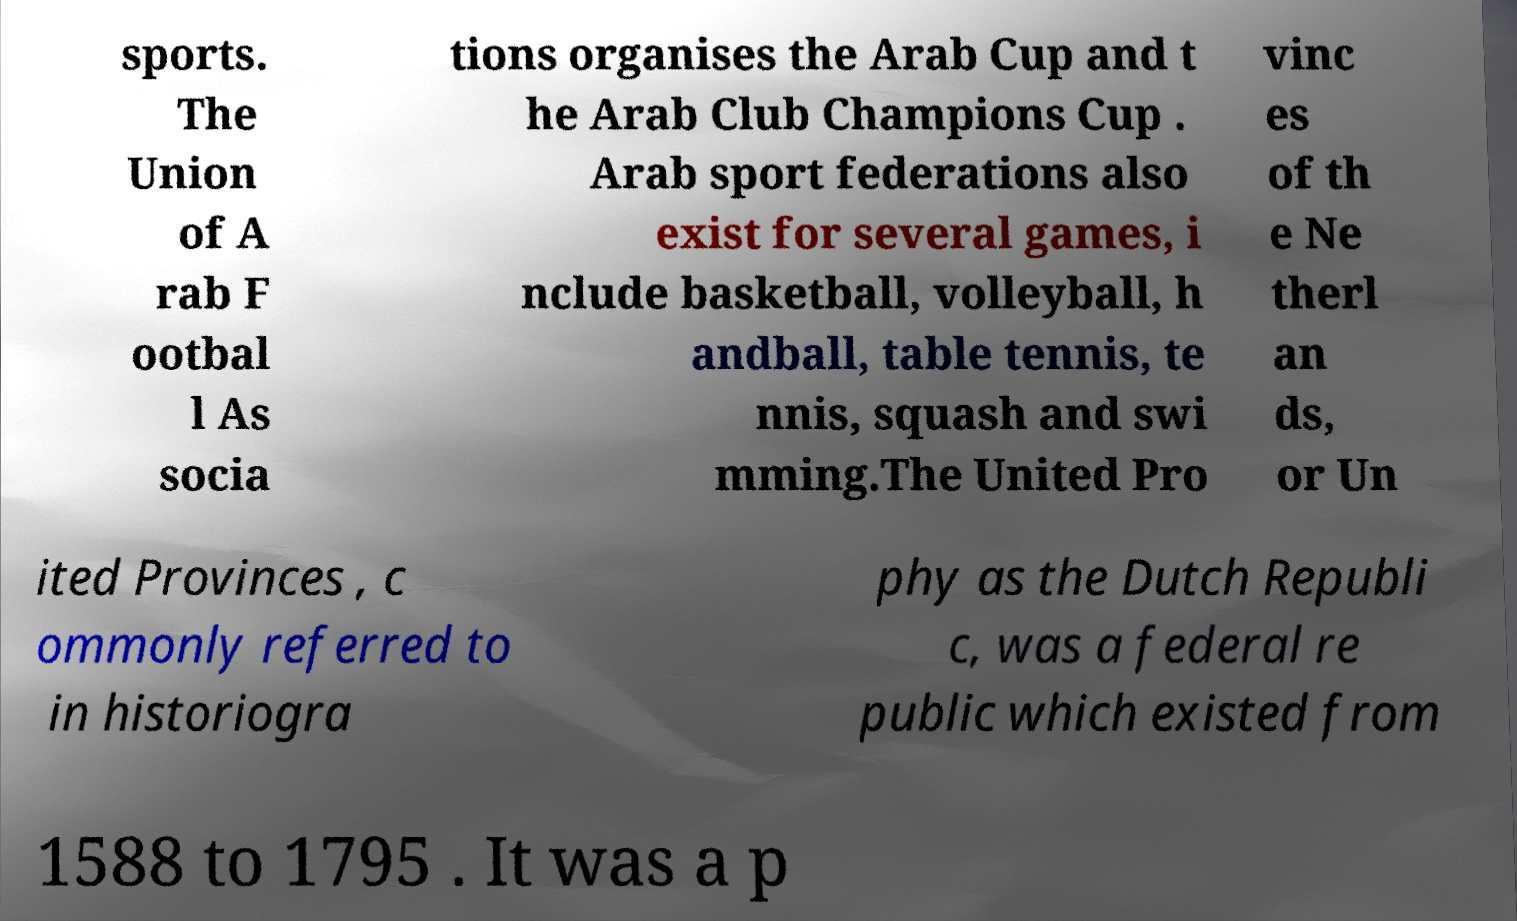For documentation purposes, I need the text within this image transcribed. Could you provide that? sports. The Union of A rab F ootbal l As socia tions organises the Arab Cup and t he Arab Club Champions Cup . Arab sport federations also exist for several games, i nclude basketball, volleyball, h andball, table tennis, te nnis, squash and swi mming.The United Pro vinc es of th e Ne therl an ds, or Un ited Provinces , c ommonly referred to in historiogra phy as the Dutch Republi c, was a federal re public which existed from 1588 to 1795 . It was a p 